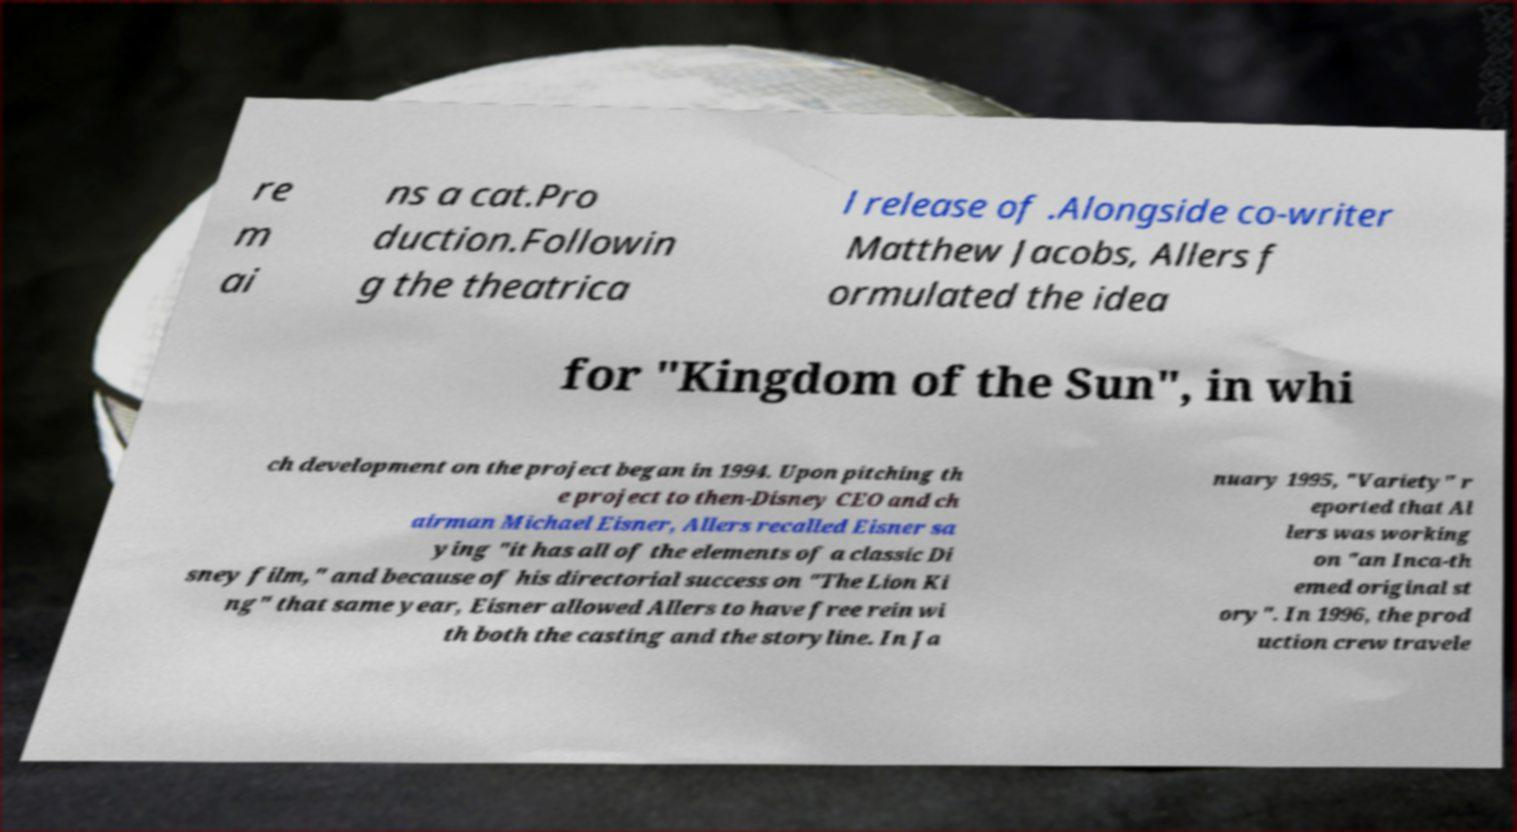What messages or text are displayed in this image? I need them in a readable, typed format. re m ai ns a cat.Pro duction.Followin g the theatrica l release of .Alongside co-writer Matthew Jacobs, Allers f ormulated the idea for "Kingdom of the Sun", in whi ch development on the project began in 1994. Upon pitching th e project to then-Disney CEO and ch airman Michael Eisner, Allers recalled Eisner sa ying "it has all of the elements of a classic Di sney film," and because of his directorial success on "The Lion Ki ng" that same year, Eisner allowed Allers to have free rein wi th both the casting and the storyline. In Ja nuary 1995, "Variety" r eported that Al lers was working on "an Inca-th emed original st ory". In 1996, the prod uction crew travele 